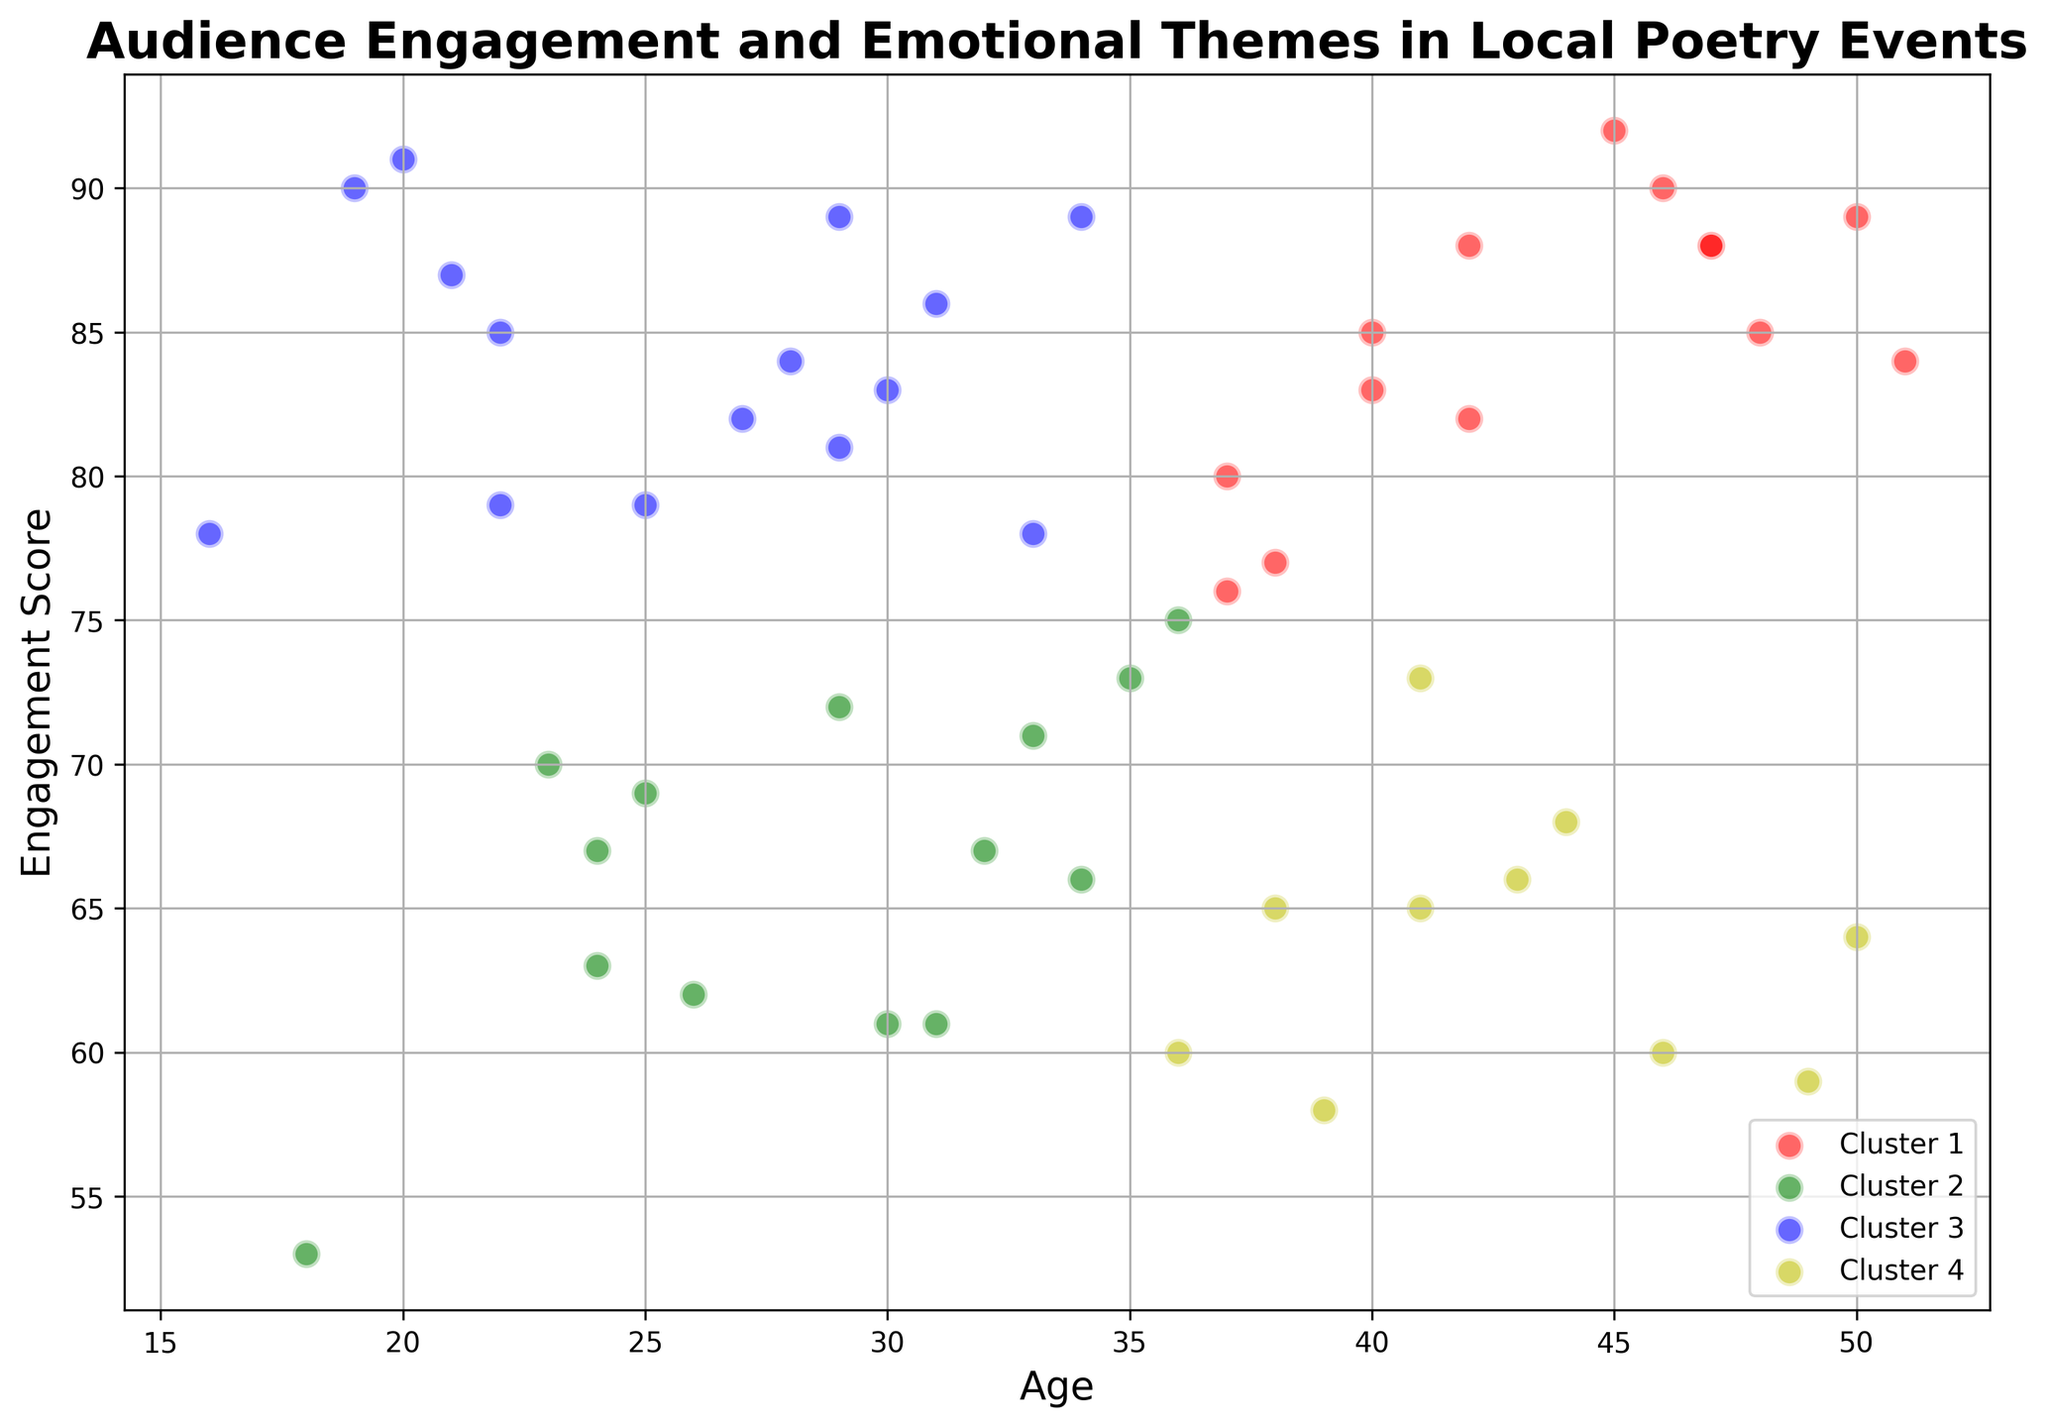Which age group has the highest engagement score? To determine this, look at the y-axis for the highest point on the plot and then check the corresponding age on the x-axis.
Answer: 20 Compare the engagement scores between the cluster with the youngest average age and the cluster with the oldest average age. Which cluster has higher engagement? Identify the clusters with the youngest and oldest average ages by finding the averages and then compare their engagement scores. The cluster with the highest average engagement score is the answer.
Answer: Cluster with the youngest average age How many clusters contain at least one data point with an engagement score above 90? Review each cluster to check if it contains at least one data point where the y-axis (engagement score) is above 90. Count how many clusters meet this criterion.
Answer: 2 What is the range of engagement scores in the cluster with the highest number of members? Identify the cluster with the most data points, check the highest and lowest y-values (engagement scores) within that cluster, and compute the range by taking the difference.
Answer: 92 - 58 = 34 Are there more individuals under 30 or over 40 in the cluster with the highest average engagement score? Identify the cluster with the highest average y-value, then count the number of individuals in this cluster who are under 30 and over 40. Compare the two counts.
Answer: Under 30 Which cluster has the widest age range? Check each cluster and determine the age range by finding the difference between the maximum and minimum ages within the cluster. The cluster with the biggest difference is the answer.
Answer: Cluster 4 What is the primary emotional theme in the cluster with the most members aged 30-40? Observe the cluster with the most members within the age range of 30-40 and note the dominant or primary emotional theme among those individuals.
Answer: Sadness Does any cluster have a majority of points with the same emotional theme? If so, which theme and cluster? Look at each cluster to see if one emotional theme is more common than others within it.
Answer: No Is there a pattern in engagement scores based on age, visible in the plot? Examine the general trend in the plot to see if there is a consistent increase or decrease in engagement scores as age increases.
Answer: No clear pattern 